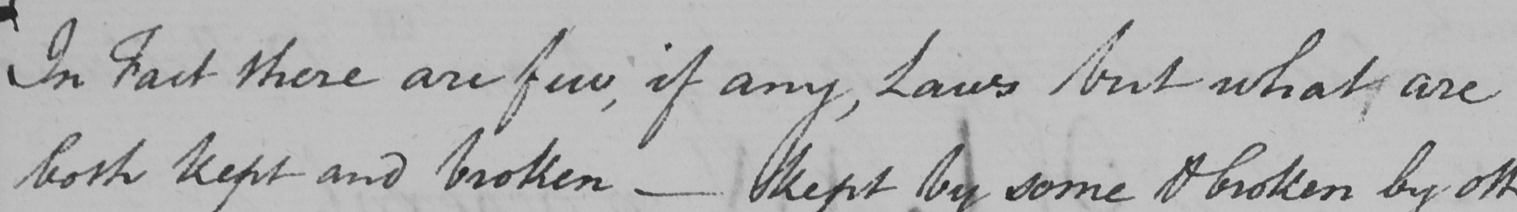Please transcribe the handwritten text in this image. In fact there are few , if any , Laws but what are 